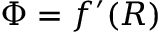Convert formula to latex. <formula><loc_0><loc_0><loc_500><loc_500>\Phi = f ^ { \prime } ( R )</formula> 